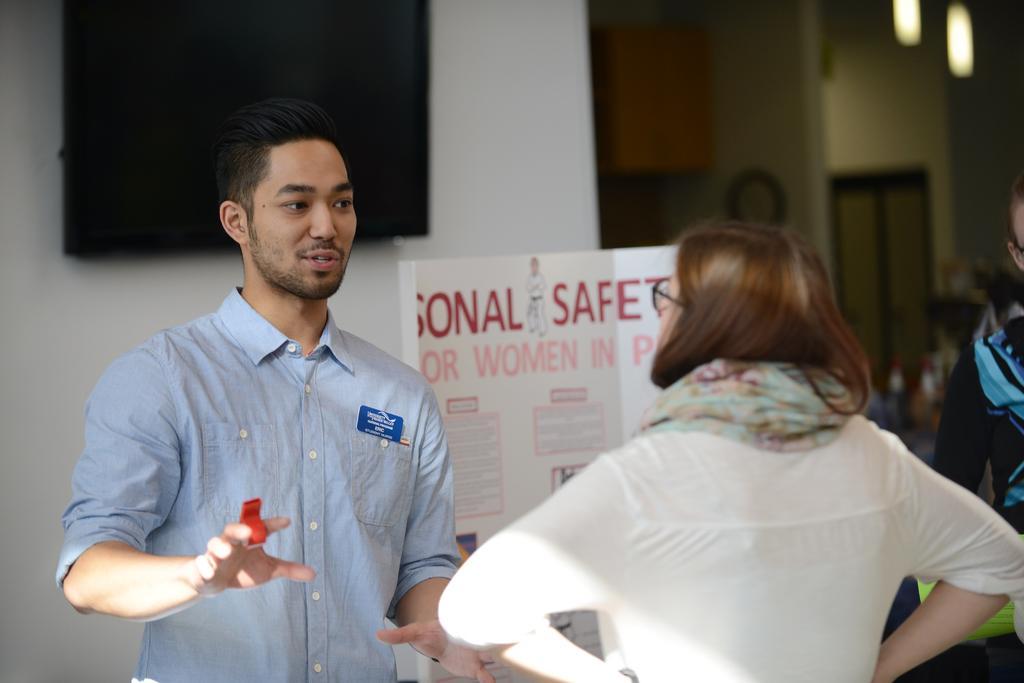Please provide a concise description of this image. In this image there are two people and a poster with text in the foreground. There is a person, a door, a frame on the wall on the right corner. We can see a television on the wall. 